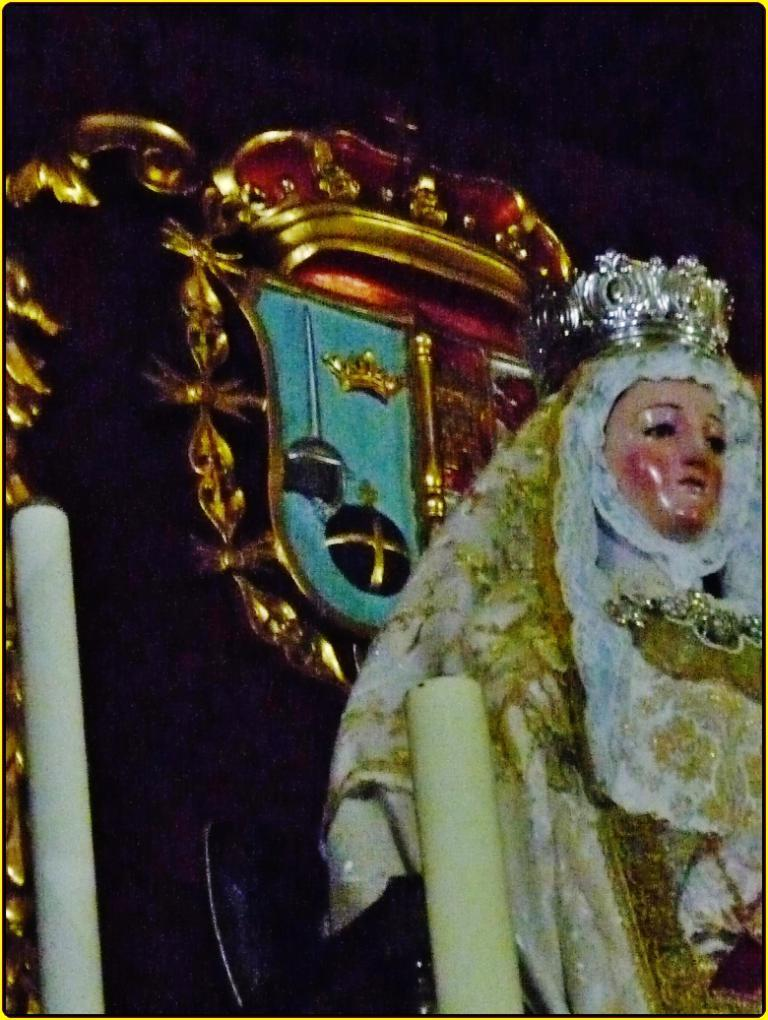What is the main subject of the image? There is a statue of a woman in the image. What is the woman depicted wearing? The woman is depicted with clothes and a crown. How many candles are in the image? There are two candles in the image. Can you describe the background of the image? The background of the image is dark. What type of pear can be seen hanging from the statue's crown in the image? There is no pear present in the image, nor is it hanging from the statue's crown. 